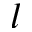<formula> <loc_0><loc_0><loc_500><loc_500>l</formula> 